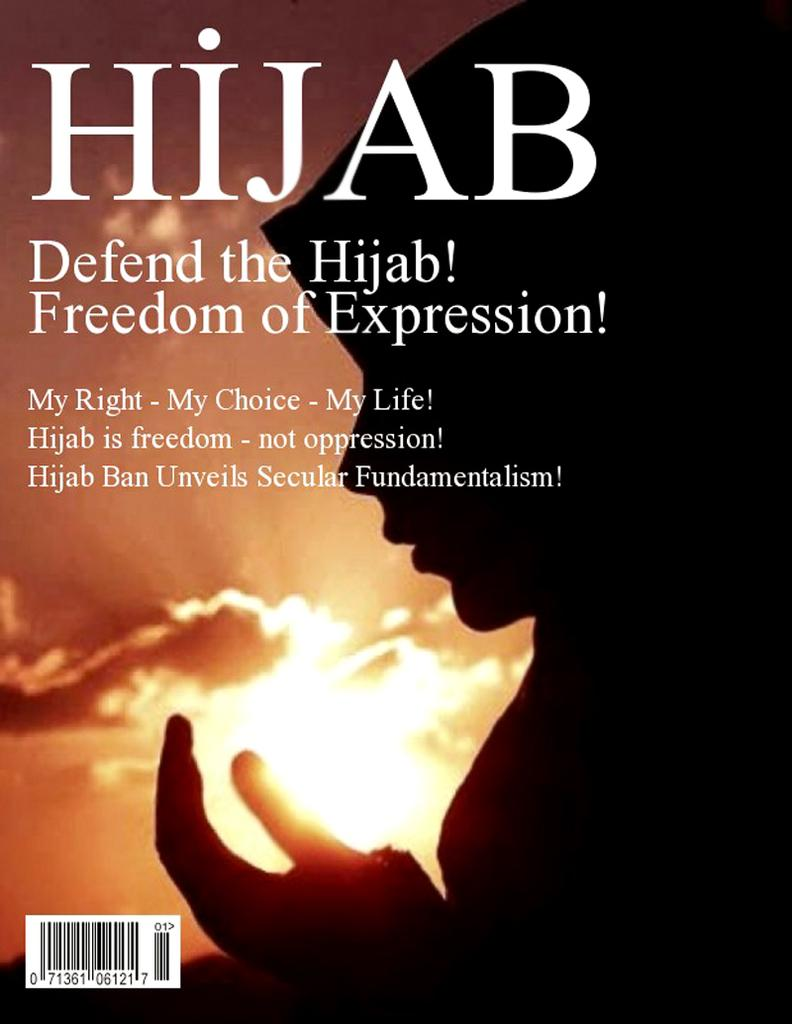<image>
Create a compact narrative representing the image presented. A book that reads "Defend the Hijab" is on display with a woman wearing a Hijab 